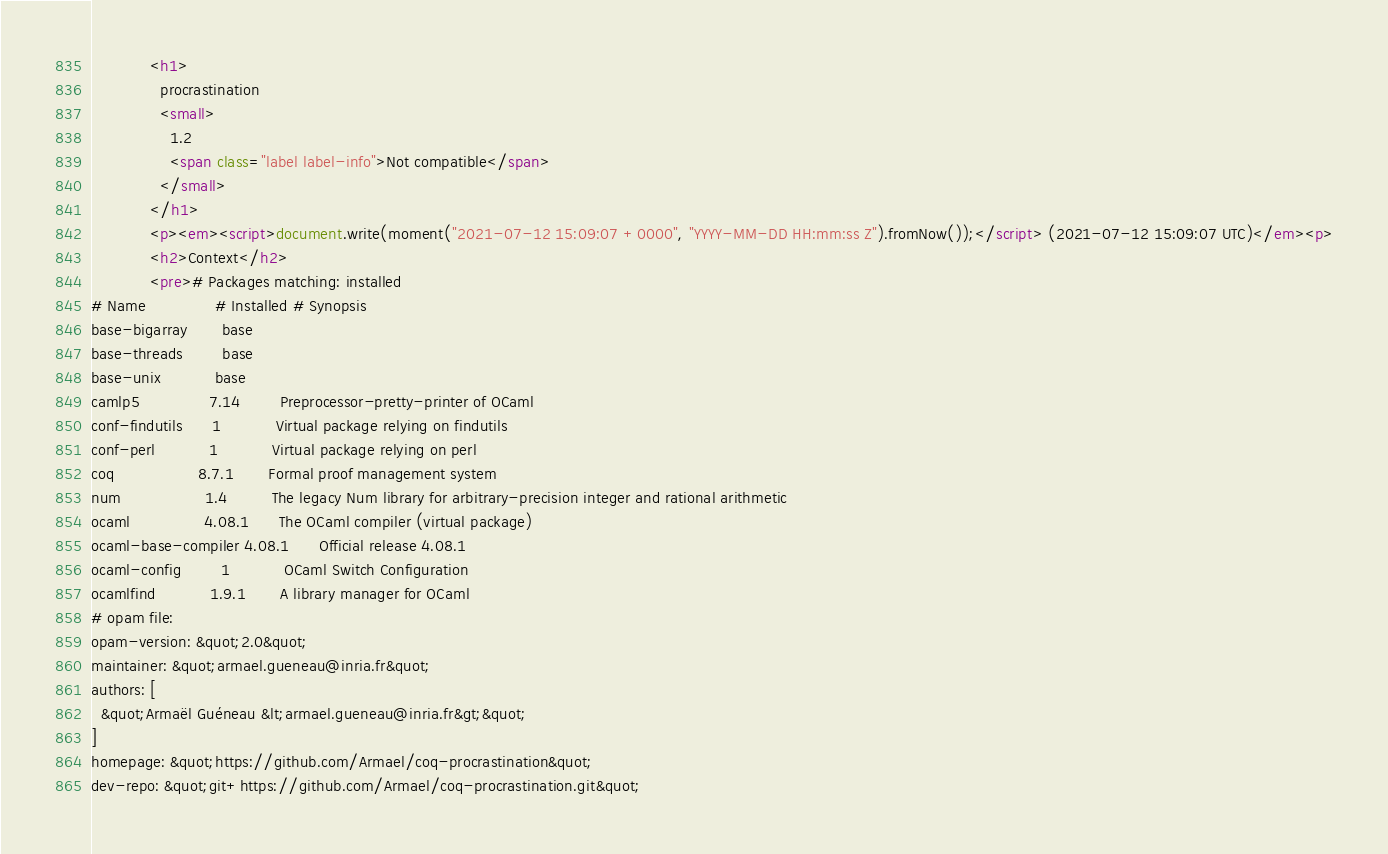<code> <loc_0><loc_0><loc_500><loc_500><_HTML_>            <h1>
              procrastination
              <small>
                1.2
                <span class="label label-info">Not compatible</span>
              </small>
            </h1>
            <p><em><script>document.write(moment("2021-07-12 15:09:07 +0000", "YYYY-MM-DD HH:mm:ss Z").fromNow());</script> (2021-07-12 15:09:07 UTC)</em><p>
            <h2>Context</h2>
            <pre># Packages matching: installed
# Name              # Installed # Synopsis
base-bigarray       base
base-threads        base
base-unix           base
camlp5              7.14        Preprocessor-pretty-printer of OCaml
conf-findutils      1           Virtual package relying on findutils
conf-perl           1           Virtual package relying on perl
coq                 8.7.1       Formal proof management system
num                 1.4         The legacy Num library for arbitrary-precision integer and rational arithmetic
ocaml               4.08.1      The OCaml compiler (virtual package)
ocaml-base-compiler 4.08.1      Official release 4.08.1
ocaml-config        1           OCaml Switch Configuration
ocamlfind           1.9.1       A library manager for OCaml
# opam file:
opam-version: &quot;2.0&quot;
maintainer: &quot;armael.gueneau@inria.fr&quot;
authors: [
  &quot;Armaël Guéneau &lt;armael.gueneau@inria.fr&gt;&quot;
]
homepage: &quot;https://github.com/Armael/coq-procrastination&quot;
dev-repo: &quot;git+https://github.com/Armael/coq-procrastination.git&quot;</code> 